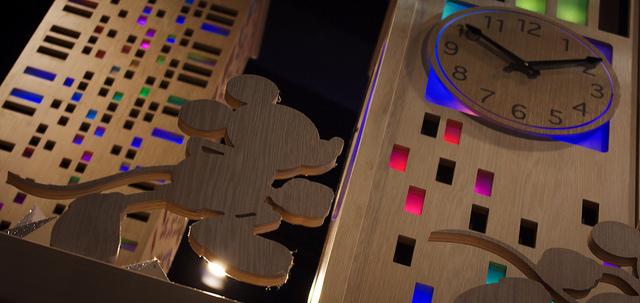What color is the  clock?
Short answer required. Brown. Does the clock have numbers?
Concise answer only. Yes. What color is the face of the clock?
Short answer required. Brown. Is that a cartoon character?
Short answer required. Yes. What time does the clock say?
Answer briefly. 10:10. 